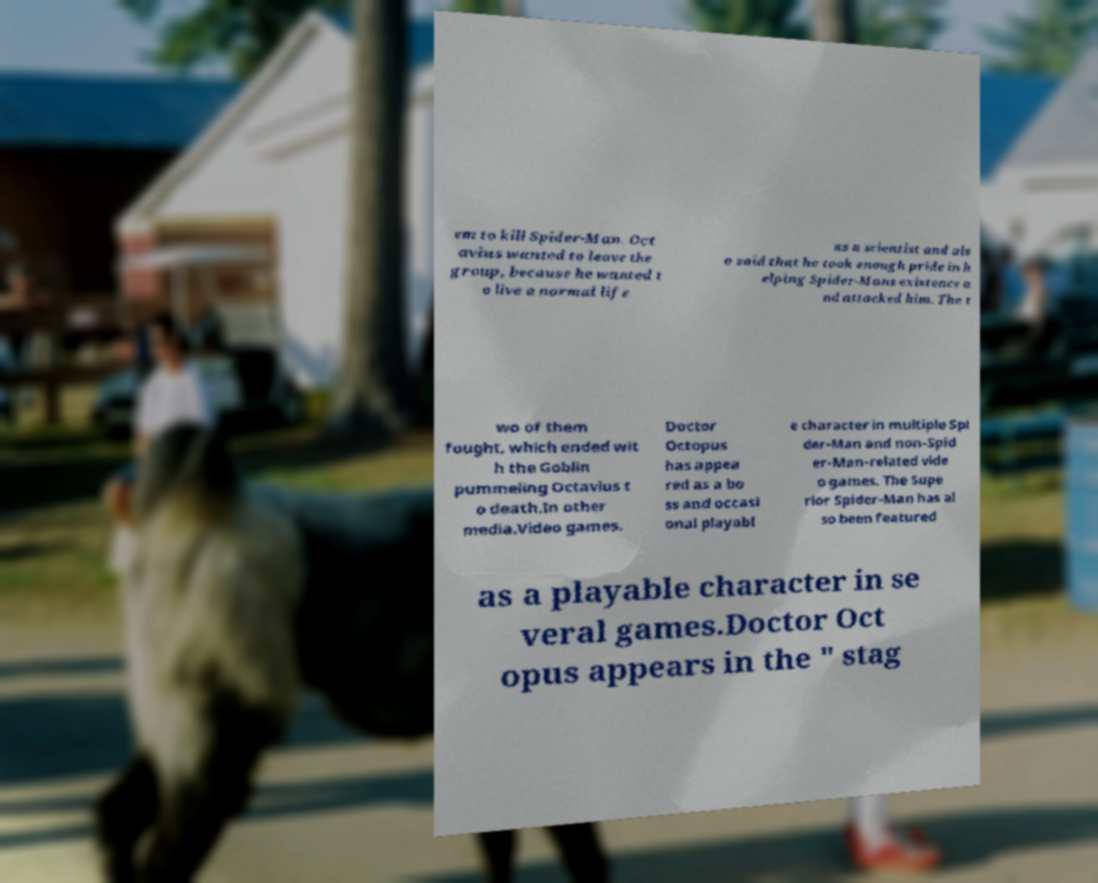What messages or text are displayed in this image? I need them in a readable, typed format. em to kill Spider-Man. Oct avius wanted to leave the group, because he wanted t o live a normal life as a scientist and als o said that he took enough pride in h elping Spider-Mans existence a nd attacked him. The t wo of them fought, which ended wit h the Goblin pummeling Octavius t o death.In other media.Video games. Doctor Octopus has appea red as a bo ss and occasi onal playabl e character in multiple Spi der-Man and non-Spid er-Man-related vide o games. The Supe rior Spider-Man has al so been featured as a playable character in se veral games.Doctor Oct opus appears in the " stag 